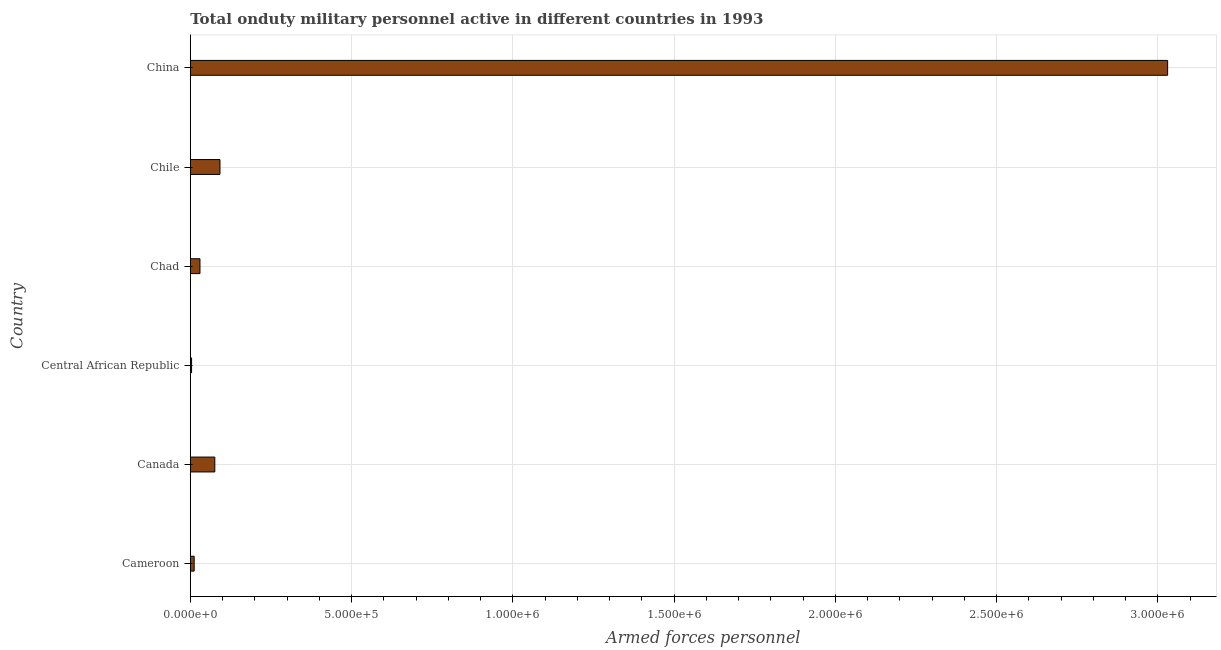Does the graph contain any zero values?
Keep it short and to the point. No. What is the title of the graph?
Your answer should be compact. Total onduty military personnel active in different countries in 1993. What is the label or title of the X-axis?
Offer a terse response. Armed forces personnel. What is the number of armed forces personnel in Cameroon?
Provide a short and direct response. 1.20e+04. Across all countries, what is the maximum number of armed forces personnel?
Provide a short and direct response. 3.03e+06. Across all countries, what is the minimum number of armed forces personnel?
Provide a short and direct response. 4000. In which country was the number of armed forces personnel maximum?
Your answer should be compact. China. In which country was the number of armed forces personnel minimum?
Provide a short and direct response. Central African Republic. What is the sum of the number of armed forces personnel?
Your answer should be very brief. 3.24e+06. What is the difference between the number of armed forces personnel in Canada and China?
Keep it short and to the point. -2.95e+06. What is the average number of armed forces personnel per country?
Provide a succinct answer. 5.41e+05. What is the median number of armed forces personnel?
Your answer should be compact. 5.30e+04. What is the ratio of the number of armed forces personnel in Central African Republic to that in China?
Provide a short and direct response. 0. Is the number of armed forces personnel in Chad less than that in Chile?
Your response must be concise. Yes. What is the difference between the highest and the second highest number of armed forces personnel?
Make the answer very short. 2.94e+06. Is the sum of the number of armed forces personnel in Cameroon and Central African Republic greater than the maximum number of armed forces personnel across all countries?
Offer a very short reply. No. What is the difference between the highest and the lowest number of armed forces personnel?
Ensure brevity in your answer.  3.03e+06. Are all the bars in the graph horizontal?
Offer a terse response. Yes. Are the values on the major ticks of X-axis written in scientific E-notation?
Offer a very short reply. Yes. What is the Armed forces personnel of Cameroon?
Provide a succinct answer. 1.20e+04. What is the Armed forces personnel in Canada?
Your answer should be very brief. 7.60e+04. What is the Armed forces personnel of Central African Republic?
Offer a very short reply. 4000. What is the Armed forces personnel in Chad?
Your response must be concise. 3.00e+04. What is the Armed forces personnel in Chile?
Your answer should be very brief. 9.20e+04. What is the Armed forces personnel in China?
Ensure brevity in your answer.  3.03e+06. What is the difference between the Armed forces personnel in Cameroon and Canada?
Provide a short and direct response. -6.40e+04. What is the difference between the Armed forces personnel in Cameroon and Central African Republic?
Your answer should be very brief. 8000. What is the difference between the Armed forces personnel in Cameroon and Chad?
Your response must be concise. -1.80e+04. What is the difference between the Armed forces personnel in Cameroon and Chile?
Provide a succinct answer. -8.00e+04. What is the difference between the Armed forces personnel in Cameroon and China?
Your response must be concise. -3.02e+06. What is the difference between the Armed forces personnel in Canada and Central African Republic?
Keep it short and to the point. 7.20e+04. What is the difference between the Armed forces personnel in Canada and Chad?
Offer a terse response. 4.60e+04. What is the difference between the Armed forces personnel in Canada and Chile?
Keep it short and to the point. -1.60e+04. What is the difference between the Armed forces personnel in Canada and China?
Make the answer very short. -2.95e+06. What is the difference between the Armed forces personnel in Central African Republic and Chad?
Your answer should be very brief. -2.60e+04. What is the difference between the Armed forces personnel in Central African Republic and Chile?
Provide a short and direct response. -8.80e+04. What is the difference between the Armed forces personnel in Central African Republic and China?
Ensure brevity in your answer.  -3.03e+06. What is the difference between the Armed forces personnel in Chad and Chile?
Your answer should be compact. -6.20e+04. What is the difference between the Armed forces personnel in Chad and China?
Give a very brief answer. -3.00e+06. What is the difference between the Armed forces personnel in Chile and China?
Keep it short and to the point. -2.94e+06. What is the ratio of the Armed forces personnel in Cameroon to that in Canada?
Offer a very short reply. 0.16. What is the ratio of the Armed forces personnel in Cameroon to that in Central African Republic?
Your response must be concise. 3. What is the ratio of the Armed forces personnel in Cameroon to that in Chile?
Provide a succinct answer. 0.13. What is the ratio of the Armed forces personnel in Cameroon to that in China?
Keep it short and to the point. 0. What is the ratio of the Armed forces personnel in Canada to that in Central African Republic?
Your response must be concise. 19. What is the ratio of the Armed forces personnel in Canada to that in Chad?
Offer a very short reply. 2.53. What is the ratio of the Armed forces personnel in Canada to that in Chile?
Make the answer very short. 0.83. What is the ratio of the Armed forces personnel in Canada to that in China?
Offer a terse response. 0.03. What is the ratio of the Armed forces personnel in Central African Republic to that in Chad?
Offer a terse response. 0.13. What is the ratio of the Armed forces personnel in Central African Republic to that in Chile?
Your answer should be compact. 0.04. What is the ratio of the Armed forces personnel in Central African Republic to that in China?
Your answer should be compact. 0. What is the ratio of the Armed forces personnel in Chad to that in Chile?
Keep it short and to the point. 0.33. What is the ratio of the Armed forces personnel in Chile to that in China?
Provide a short and direct response. 0.03. 